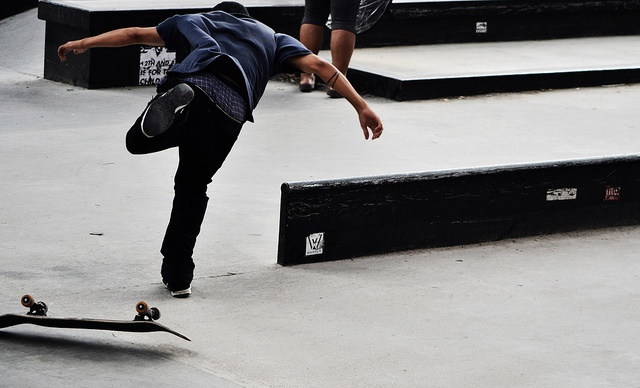Describe the objects in this image and their specific colors. I can see people in black, navy, maroon, and gray tones, people in black, maroon, and brown tones, and skateboard in black, gray, darkgray, and lightgray tones in this image. 